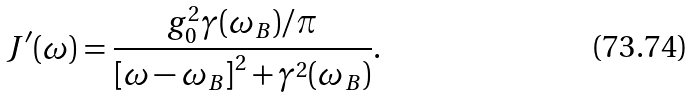Convert formula to latex. <formula><loc_0><loc_0><loc_500><loc_500>J ^ { \prime } ( \omega ) = \frac { g _ { 0 } ^ { 2 } \gamma ( { \omega } _ { B } ) / \pi } { \left [ \omega - { \omega } _ { B } \right ] ^ { 2 } + \gamma ^ { 2 } ( { \omega } _ { B } ) } .</formula> 